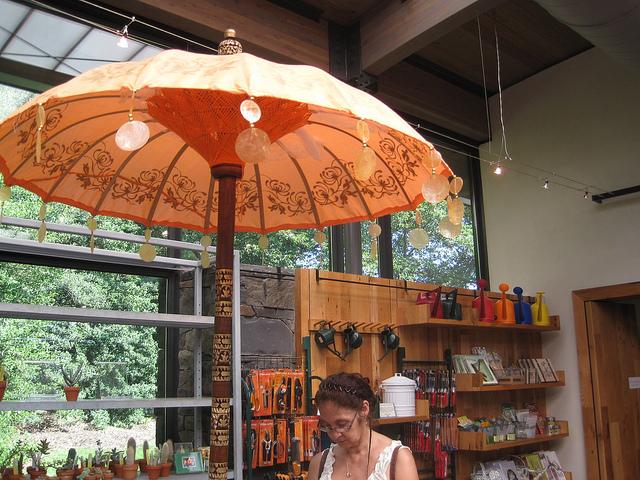Where are the succulents?
Quick response, please. Shelf. Is this an indoor scene?
Short answer required. Yes. Is this indoors or outdoors?
Keep it brief. Indoors. What is the sex of the person in the image?
Short answer required. Female. What color is the umbrella?
Keep it brief. Orange. 